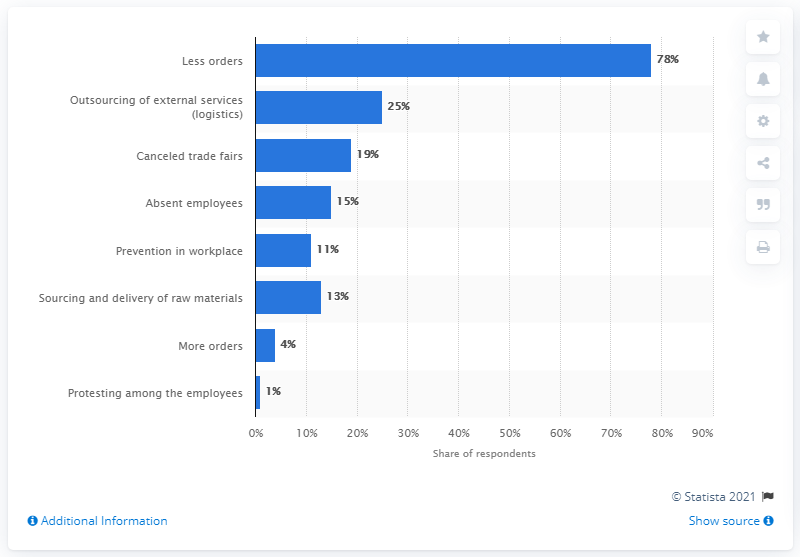Highlight a few significant elements in this photo. A recent survey of entrepreneurs revealed that a significant number of them, 19%, stated that trade fair cancellations were a problem for their businesses. A significant percentage of Italian companies in the food industry have reported a decline in orders due to the COVID-19 pandemic, with 78% reporting a significant decrease. 